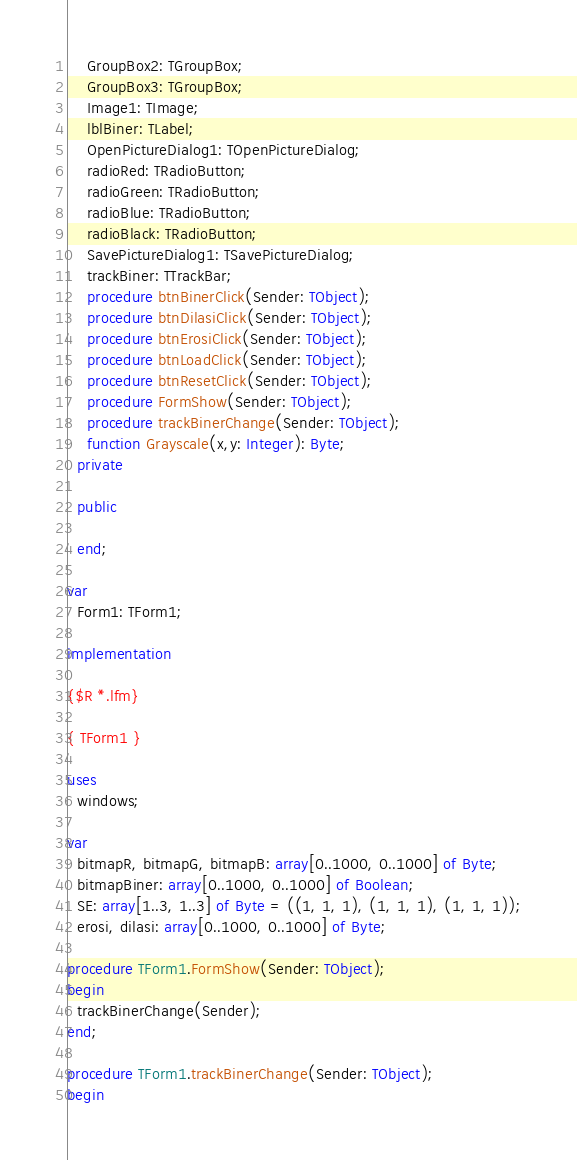<code> <loc_0><loc_0><loc_500><loc_500><_Pascal_>    GroupBox2: TGroupBox;
    GroupBox3: TGroupBox;
    Image1: TImage;
    lblBiner: TLabel;
    OpenPictureDialog1: TOpenPictureDialog;
    radioRed: TRadioButton;
    radioGreen: TRadioButton;
    radioBlue: TRadioButton;
    radioBlack: TRadioButton;
    SavePictureDialog1: TSavePictureDialog;
    trackBiner: TTrackBar;
    procedure btnBinerClick(Sender: TObject);
    procedure btnDilasiClick(Sender: TObject);
    procedure btnErosiClick(Sender: TObject);
    procedure btnLoadClick(Sender: TObject);
    procedure btnResetClick(Sender: TObject);
    procedure FormShow(Sender: TObject);
    procedure trackBinerChange(Sender: TObject);
    function Grayscale(x,y: Integer): Byte;
  private

  public

  end;

var
  Form1: TForm1;

implementation

{$R *.lfm}

{ TForm1 }

uses
  windows;

var
  bitmapR, bitmapG, bitmapB: array[0..1000, 0..1000] of Byte;
  bitmapBiner: array[0..1000, 0..1000] of Boolean;
  SE: array[1..3, 1..3] of Byte = ((1, 1, 1), (1, 1, 1), (1, 1, 1));
  erosi, dilasi: array[0..1000, 0..1000] of Byte;

procedure TForm1.FormShow(Sender: TObject);
begin
  trackBinerChange(Sender);
end;

procedure TForm1.trackBinerChange(Sender: TObject);
begin</code> 